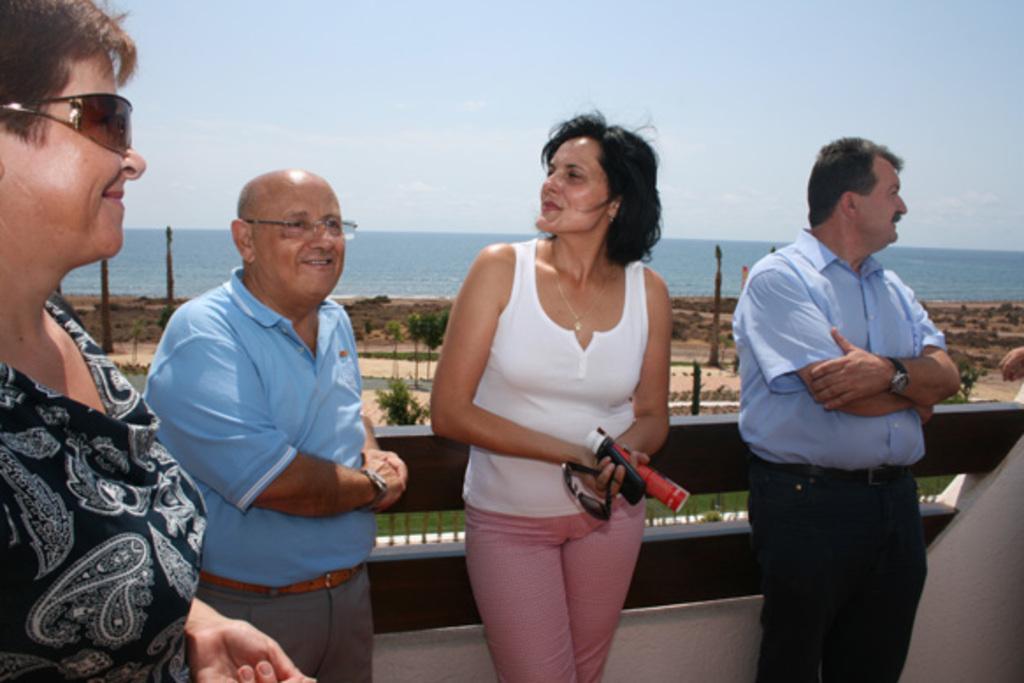Can you describe this image briefly? In the background we can see sky and sea. These are plants and here we can see grass. We can see people standing. This woman is holding mobile, bottle and goggles in her hands. 